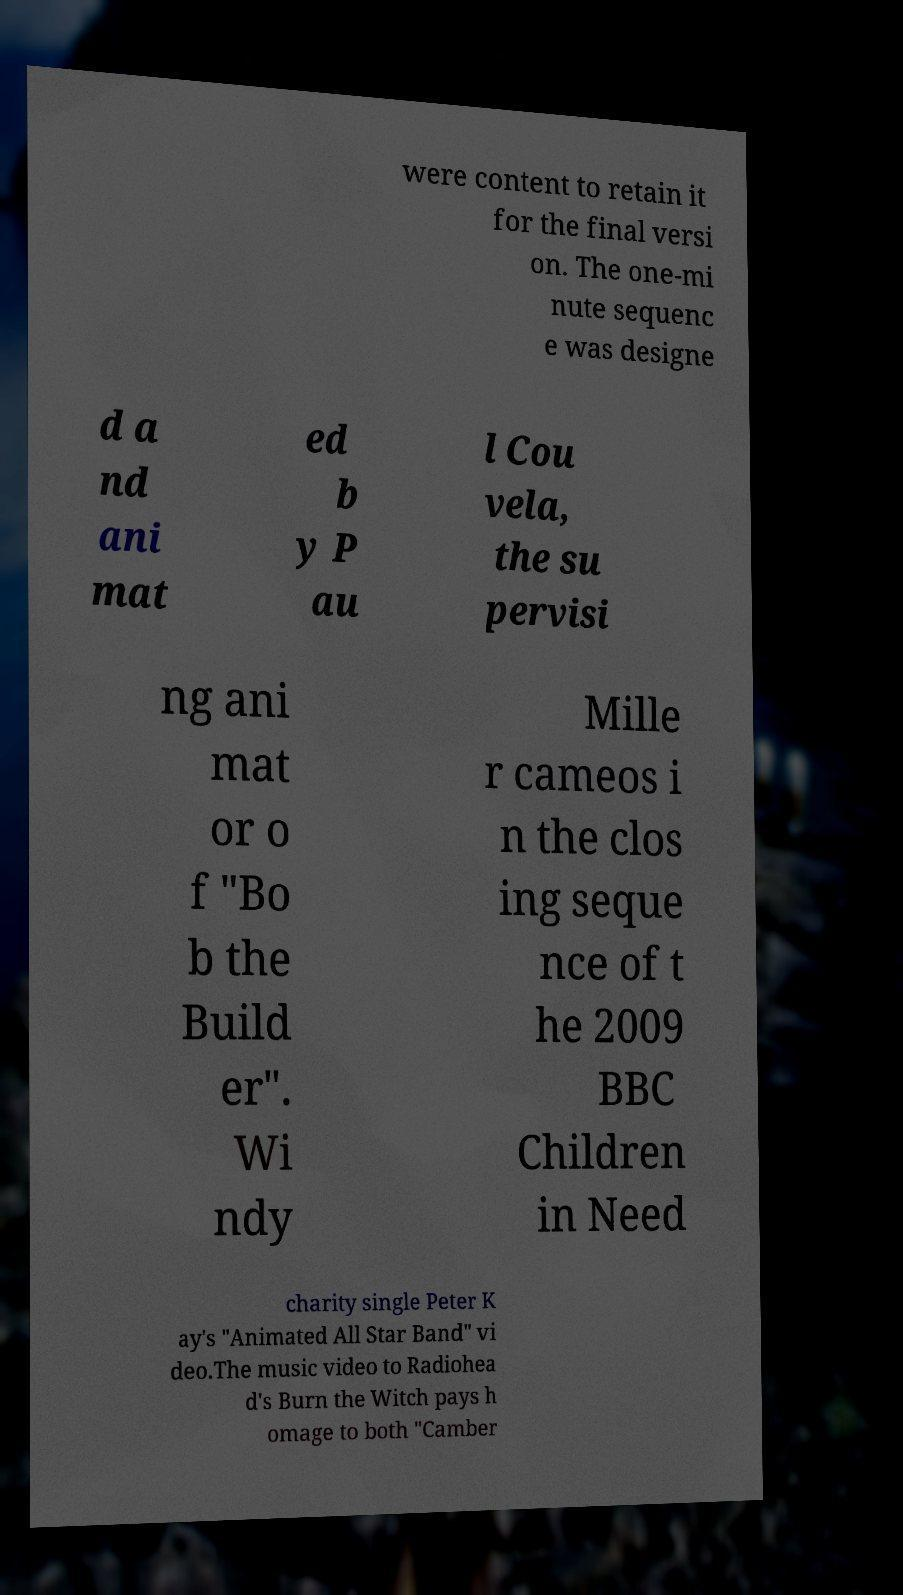For documentation purposes, I need the text within this image transcribed. Could you provide that? were content to retain it for the final versi on. The one-mi nute sequenc e was designe d a nd ani mat ed b y P au l Cou vela, the su pervisi ng ani mat or o f "Bo b the Build er". Wi ndy Mille r cameos i n the clos ing seque nce of t he 2009 BBC Children in Need charity single Peter K ay's "Animated All Star Band" vi deo.The music video to Radiohea d's Burn the Witch pays h omage to both "Camber 